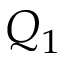<formula> <loc_0><loc_0><loc_500><loc_500>Q _ { 1 }</formula> 